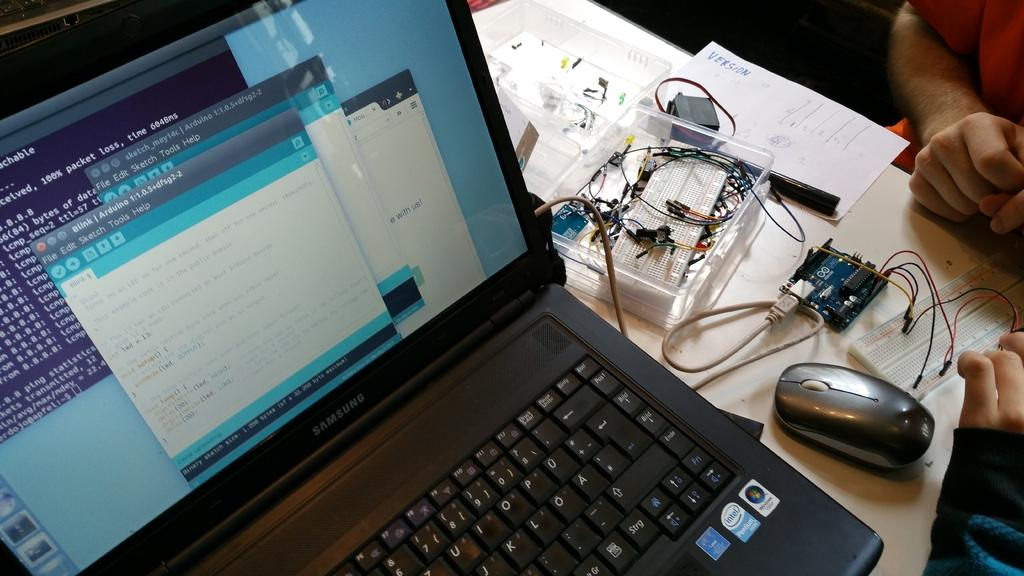<image>
Render a clear and concise summary of the photo. Person using a Samsung laptop with a blue sticker that says intel. 